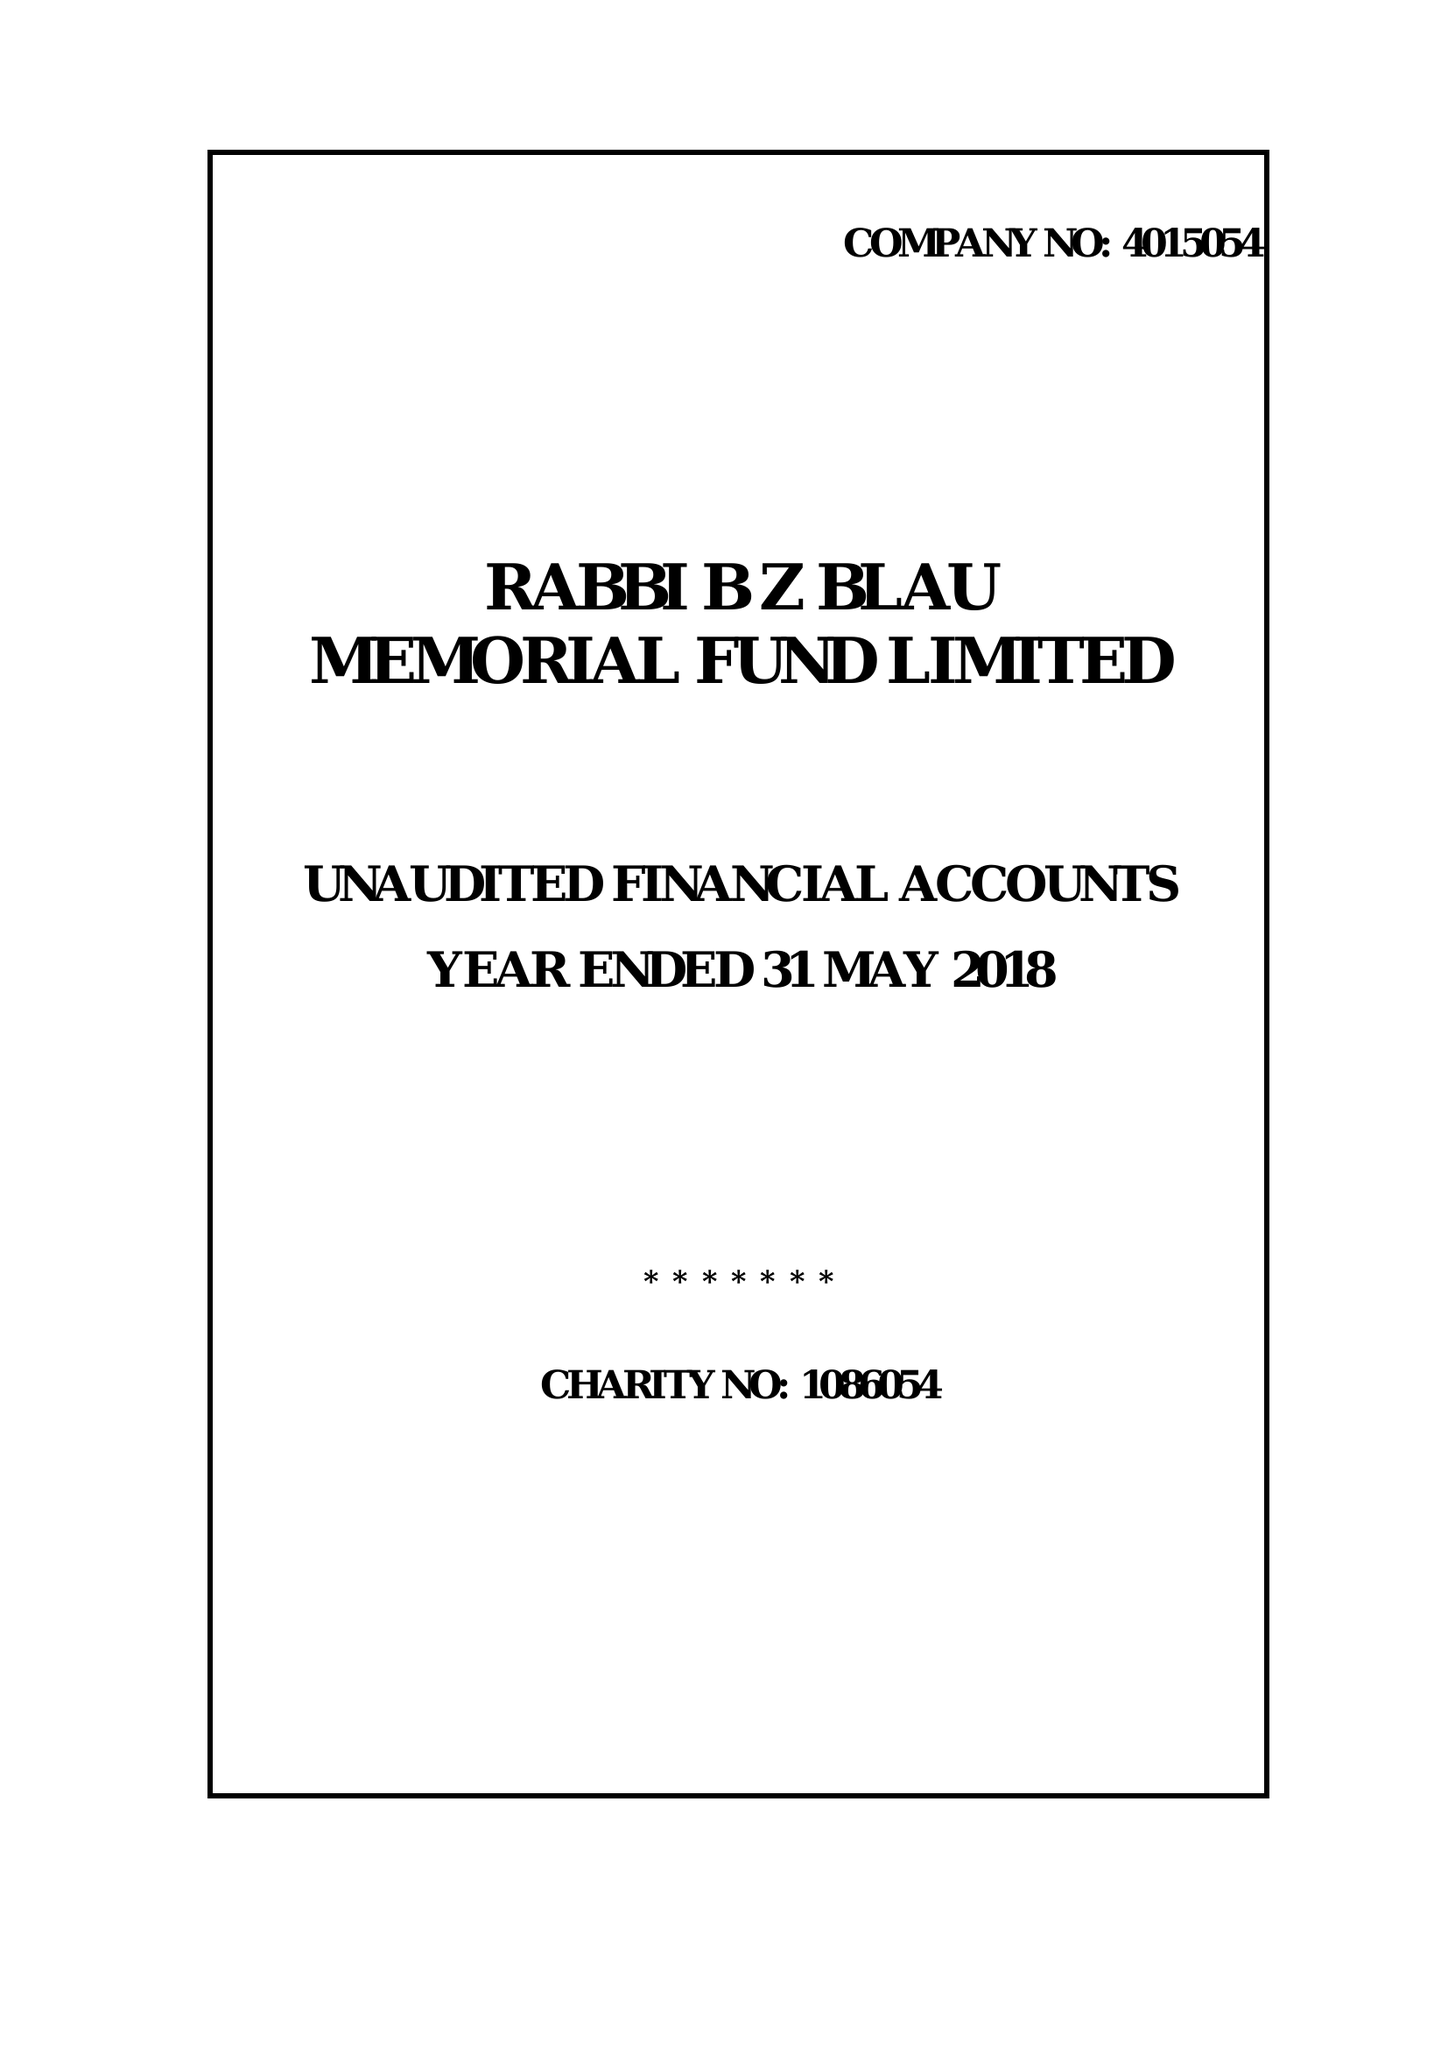What is the value for the address__street_line?
Answer the question using a single word or phrase. 10 SCHONFELD SQUARE 